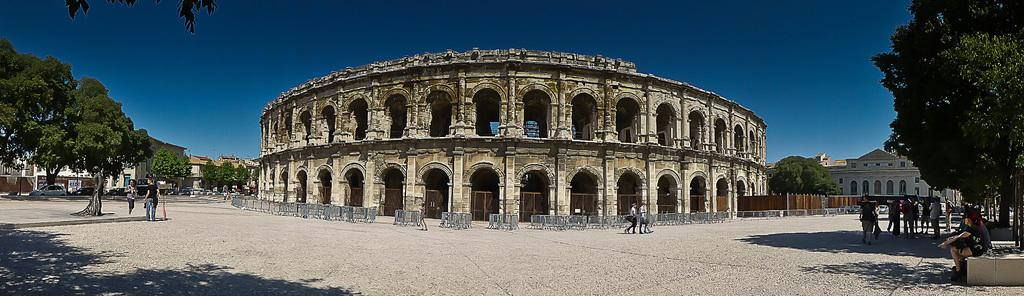What color is the sky in the image? The sky is blue in the image. What type of structures can be seen in the image? There are buildings in the image. Who or what is present in the image besides the buildings? There are people and trees in the image. How many chairs are visible in the image? There are no chairs present in the image. What part of the human body is shown in the image? There are no human body parts visible in the image; only whole people are present. 